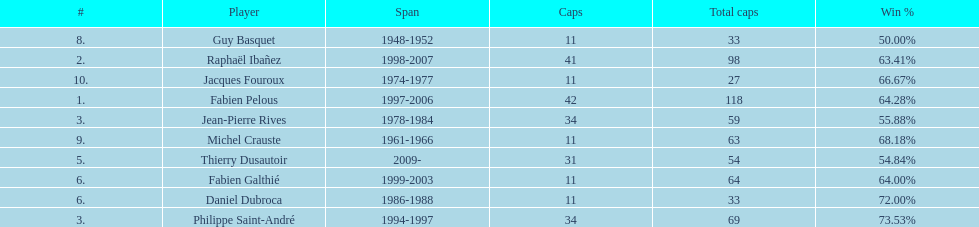How long did michel crauste serve as captain? 1961-1966. 